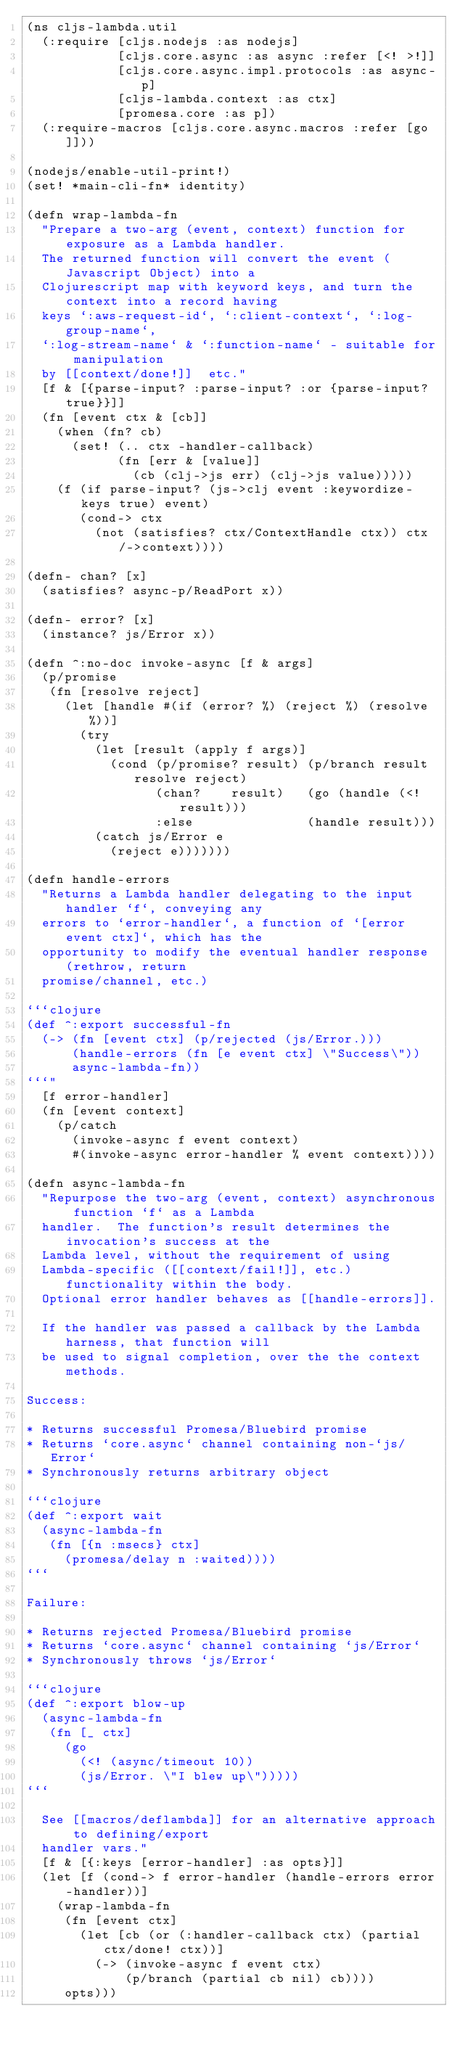<code> <loc_0><loc_0><loc_500><loc_500><_Clojure_>(ns cljs-lambda.util
  (:require [cljs.nodejs :as nodejs]
            [cljs.core.async :as async :refer [<! >!]]
            [cljs.core.async.impl.protocols :as async-p]
            [cljs-lambda.context :as ctx]
            [promesa.core :as p])
  (:require-macros [cljs.core.async.macros :refer [go]]))

(nodejs/enable-util-print!)
(set! *main-cli-fn* identity)

(defn wrap-lambda-fn
  "Prepare a two-arg (event, context) function for exposure as a Lambda handler.
  The returned function will convert the event (Javascript Object) into a
  Clojurescript map with keyword keys, and turn the context into a record having
  keys `:aws-request-id`, `:client-context`, `:log-group-name`,
  `:log-stream-name` & `:function-name` - suitable for manipulation
  by [[context/done!]]  etc."
  [f & [{parse-input? :parse-input? :or {parse-input? true}}]]
  (fn [event ctx & [cb]]
    (when (fn? cb)
      (set! (.. ctx -handler-callback)
            (fn [err & [value]]
              (cb (clj->js err) (clj->js value)))))
    (f (if parse-input? (js->clj event :keywordize-keys true) event)
       (cond-> ctx
         (not (satisfies? ctx/ContextHandle ctx)) ctx/->context))))

(defn- chan? [x]
  (satisfies? async-p/ReadPort x))

(defn- error? [x]
  (instance? js/Error x))

(defn ^:no-doc invoke-async [f & args]
  (p/promise
   (fn [resolve reject]
     (let [handle #(if (error? %) (reject %) (resolve %))]
       (try
         (let [result (apply f args)]
           (cond (p/promise? result) (p/branch result resolve reject)
                 (chan?    result)   (go (handle (<! result)))
                 :else               (handle result)))
         (catch js/Error e
           (reject e)))))))

(defn handle-errors
  "Returns a Lambda handler delegating to the input handler `f`, conveying any
  errors to `error-handler`, a function of `[error event ctx]`, which has the
  opportunity to modify the eventual handler response (rethrow, return
  promise/channel, etc.)

```clojure
(def ^:export successful-fn
  (-> (fn [event ctx] (p/rejected (js/Error.)))
      (handle-errors (fn [e event ctx] \"Success\"))
      async-lambda-fn))
```"
  [f error-handler]
  (fn [event context]
    (p/catch
      (invoke-async f event context)
      #(invoke-async error-handler % event context))))

(defn async-lambda-fn
  "Repurpose the two-arg (event, context) asynchronous function `f` as a Lambda
  handler.  The function's result determines the invocation's success at the
  Lambda level, without the requirement of using
  Lambda-specific ([[context/fail!]], etc.) functionality within the body.
  Optional error handler behaves as [[handle-errors]].

  If the handler was passed a callback by the Lambda harness, that function will
  be used to signal completion, over the the context methods.

Success:

* Returns successful Promesa/Bluebird promise
* Returns `core.async` channel containing non-`js/Error`
* Synchronously returns arbitrary object

```clojure
(def ^:export wait
  (async-lambda-fn
   (fn [{n :msecs} ctx]
     (promesa/delay n :waited))))
```

Failure:

* Returns rejected Promesa/Bluebird promise
* Returns `core.async` channel containing `js/Error`
* Synchronously throws `js/Error`

```clojure
(def ^:export blow-up
  (async-lambda-fn
   (fn [_ ctx]
     (go
       (<! (async/timeout 10))
       (js/Error. \"I blew up\")))))
```

  See [[macros/deflambda]] for an alternative approach to defining/export
  handler vars."
  [f & [{:keys [error-handler] :as opts}]]
  (let [f (cond-> f error-handler (handle-errors error-handler))]
    (wrap-lambda-fn
     (fn [event ctx]
       (let [cb (or (:handler-callback ctx) (partial ctx/done! ctx))]
         (-> (invoke-async f event ctx)
             (p/branch (partial cb nil) cb))))
     opts)))
</code> 